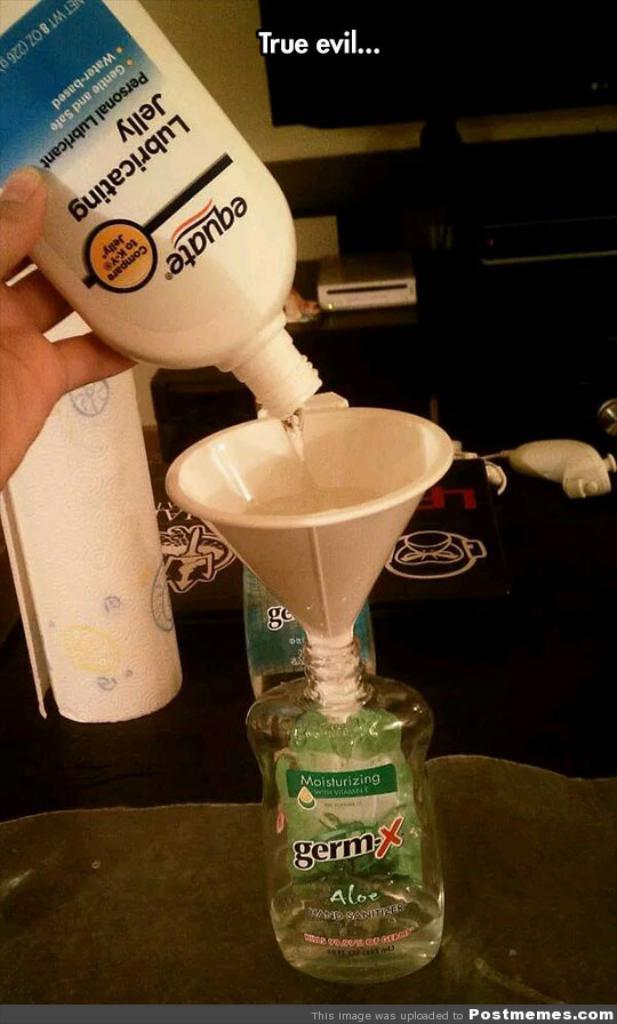How would you summarize this image in a sentence or two? On a table there is a bottle and a person is pouring some liquid in a small cap into the bottle. In the background there is a TV,table. 